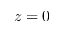<formula> <loc_0><loc_0><loc_500><loc_500>z = 0</formula> 